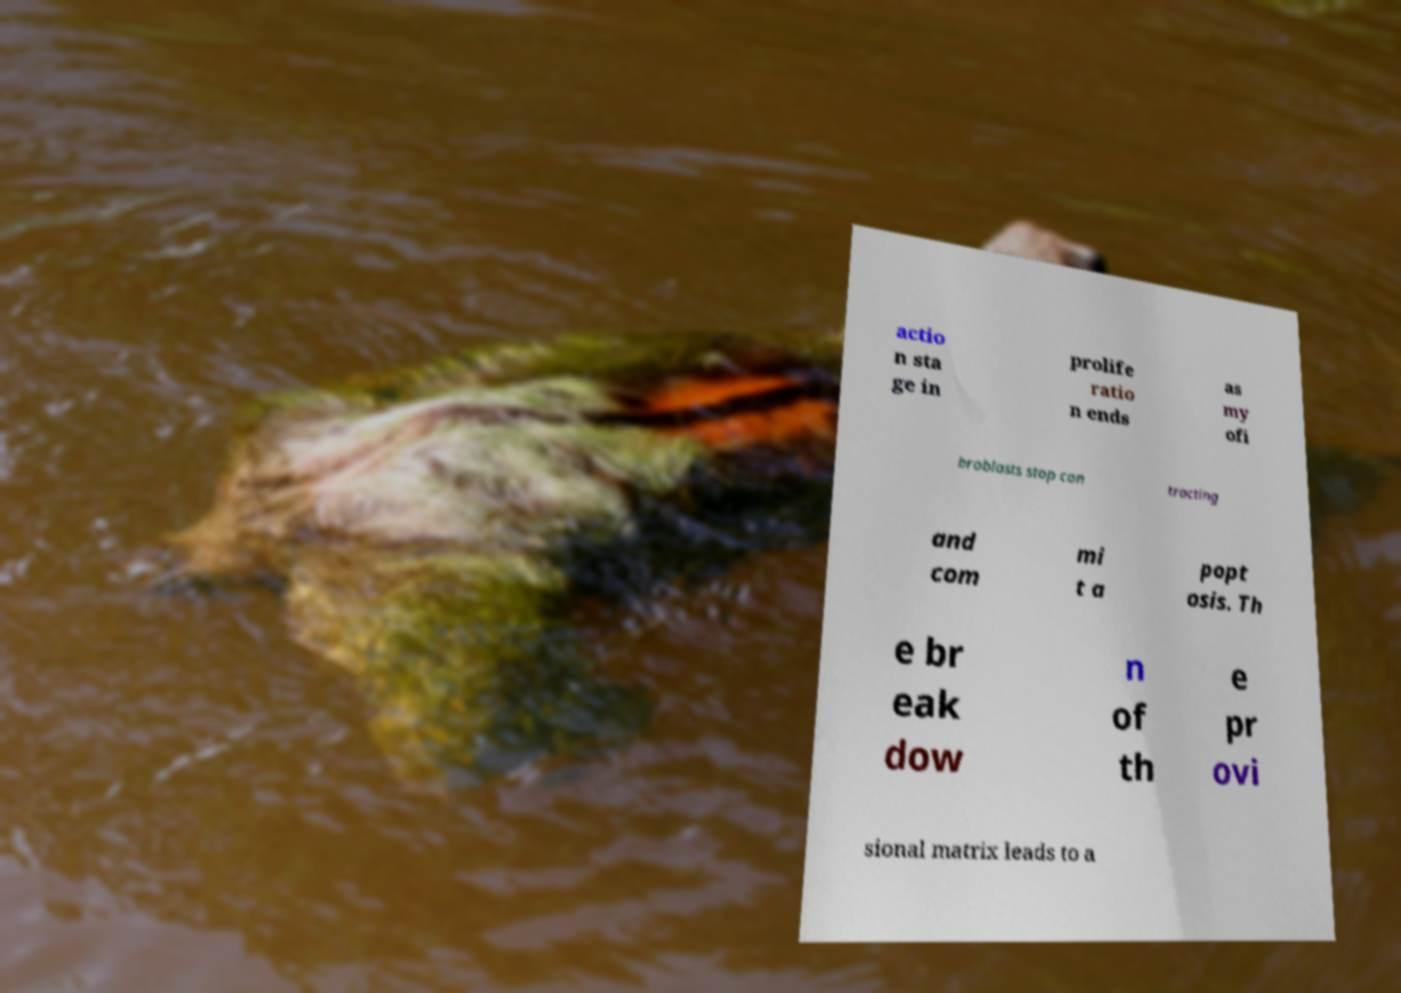Please identify and transcribe the text found in this image. actio n sta ge in prolife ratio n ends as my ofi broblasts stop con tracting and com mi t a popt osis. Th e br eak dow n of th e pr ovi sional matrix leads to a 